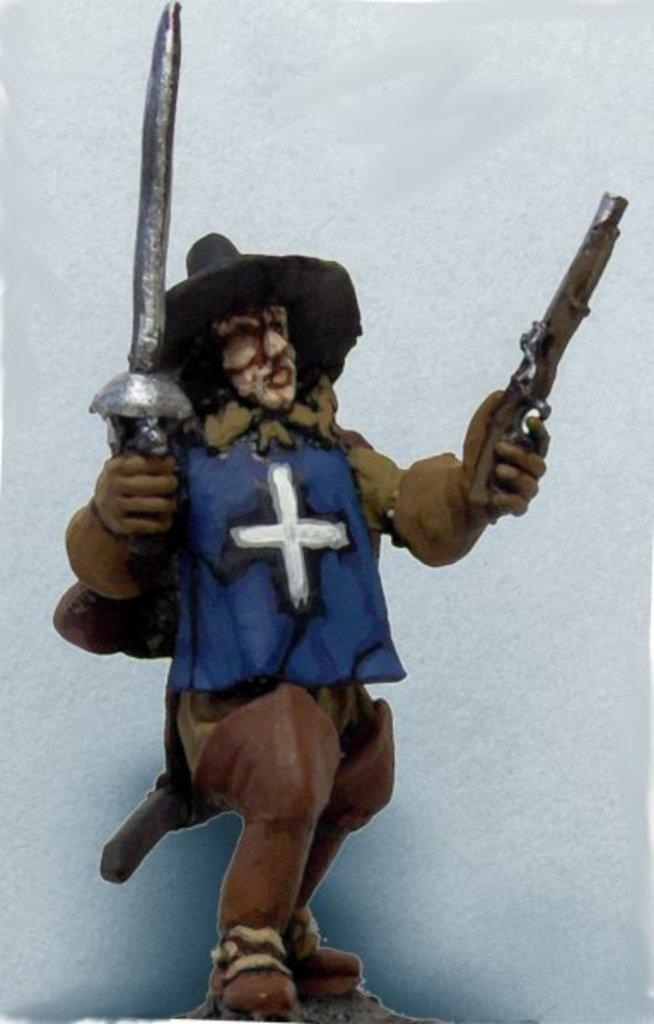What is the main subject of the image? There is a statue of a person in the image. What is the person holding in their hands? The person is holding a sword and a gun. What can be seen in the background of the image? There is a wall in the background of the image. What type of bait is the person using to catch fish in the image? There is no bait or fishing activity present in the image; it features a statue of a person holding a sword and a gun. What advice might the person's father give them in the image? There is no father or conversation present in the image; it features a statue of a person holding a sword and a gun. 